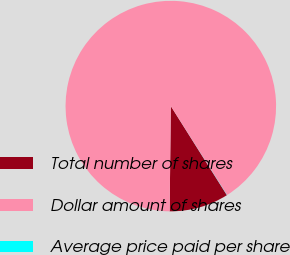Convert chart to OTSL. <chart><loc_0><loc_0><loc_500><loc_500><pie_chart><fcel>Total number of shares<fcel>Dollar amount of shares<fcel>Average price paid per share<nl><fcel>9.12%<fcel>90.85%<fcel>0.03%<nl></chart> 